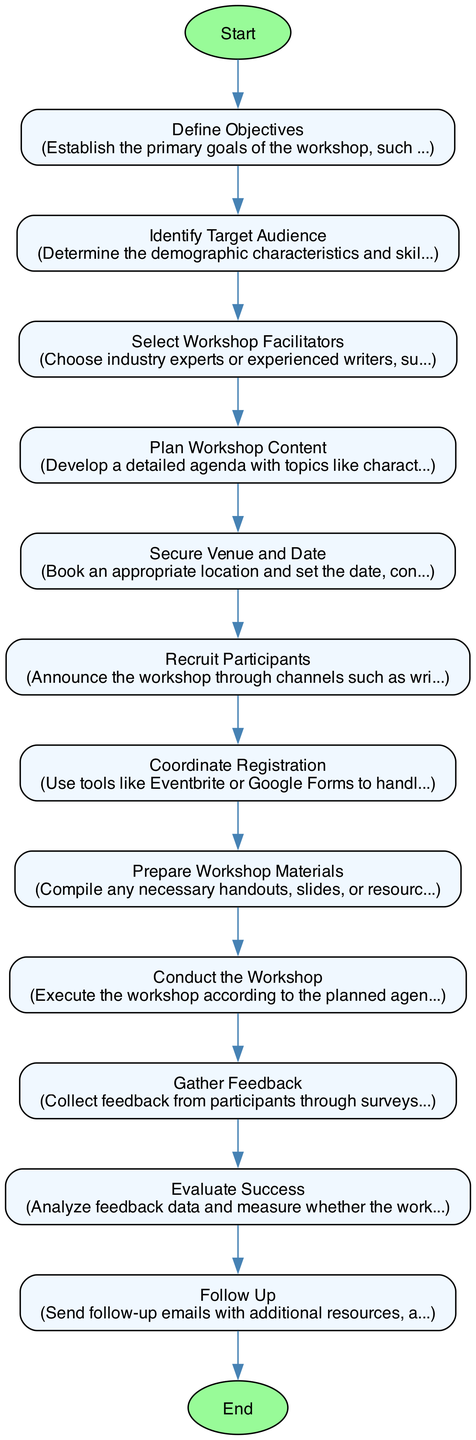What is the first step in the workshop organization process? The first step, as indicated in the diagram, is "Define Objectives." This establishes the primary goals of the workshop.
Answer: Define Objectives How many steps are there in the workflow? By counting each outlined step in the diagram, we find that there are a total of 12 distinct steps.
Answer: 12 What step involves booking a location? The diagram clearly shows that the step "Secure Venue and Date" is where booking the appropriate location takes place.
Answer: Secure Venue and Date Which step comes after "Conduct the Workshop"? Following the "Conduct the Workshop" step, the next step indicated is "Gather Feedback." This shows the sequential flow of activities.
Answer: Gather Feedback What two aspects are included in "Prepare Workshop Materials"? The description specifies that "creative and legal aspects of writing" are included in the materials preparation. Thus, both areas are emphasized.
Answer: creative and legal aspects What is the last step in the workshop organization process? According to the flowchart, the last step is labeled "Follow Up," which focuses on post-workshop engagement.
Answer: Follow Up How does the "Recruit Participants" step relate to the previous step? The "Recruit Participants" step follows directly after "Secure Venue and Date," indicating that after securing the venue, participant recruitment takes place.
Answer: Sequentially linked What is the purpose of the "Evaluate Success" step? The objective of this step is to "analyze feedback data and measure whether the workshop objectives were achieved." It ensures accountability and assessment of the workshop's effectiveness.
Answer: analyze feedback data and measure whether the workshop objectives were achieved Which node represents the beginning of the process? The diagram clearly identifies the node "Start" as the beginning of the organizational process for the workshop, indicating the starting point of the flow.
Answer: Start 